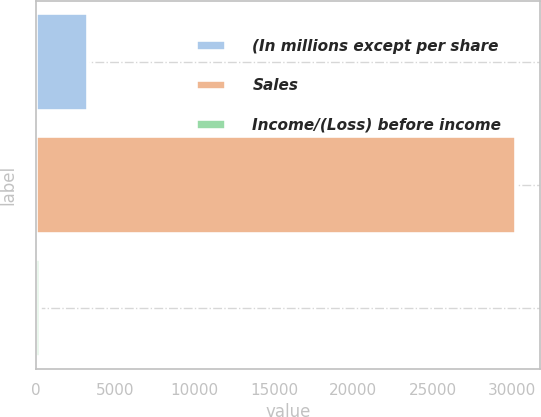<chart> <loc_0><loc_0><loc_500><loc_500><bar_chart><fcel>(In millions except per share<fcel>Sales<fcel>Income/(Loss) before income<nl><fcel>3267.8<fcel>30230<fcel>272<nl></chart> 